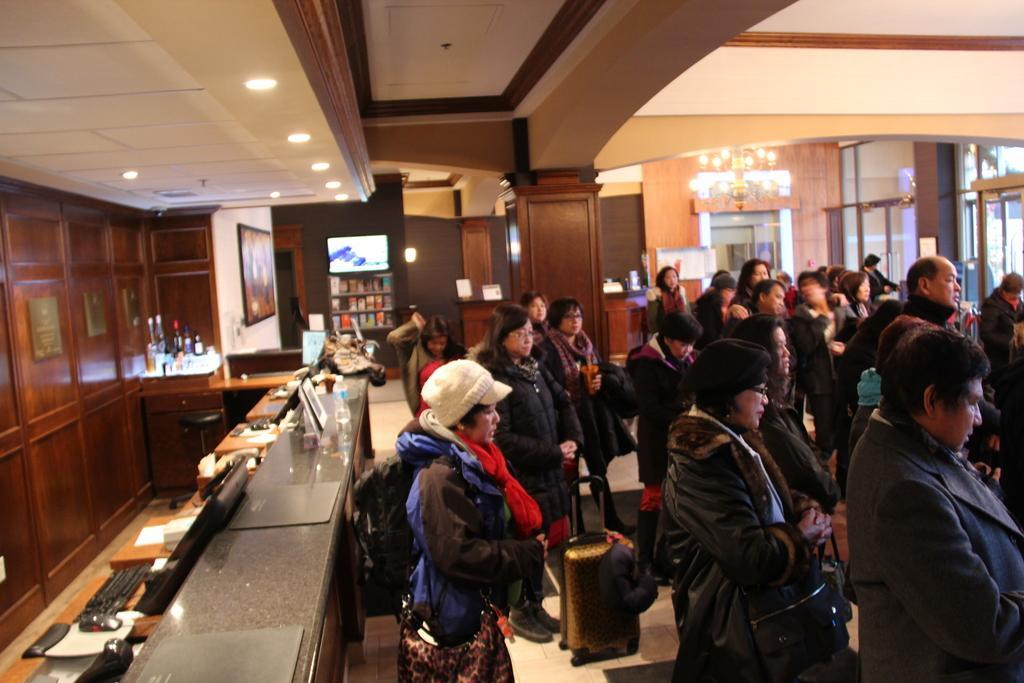Describe this image in one or two sentences. This picture is an inside view of a room. In the center of the image we can see a group of people are standing, some of them are holding bags. In the background of the image we can see books, screen, lights, wall, boards are there. On the left side of the image we can see bench, table, mouse, keyboard, screen, papers, books, bottles, cupboards, photo frame are there. At the top of the image we can see the roof and lights are there. At the bottom of the image floor is there. 